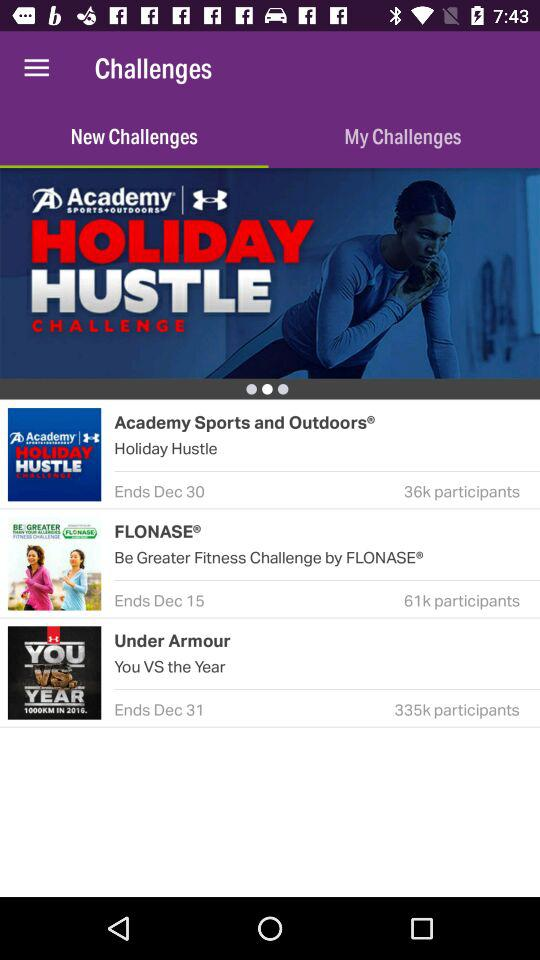What tab is selected? The selected tab is "New Challenges". 